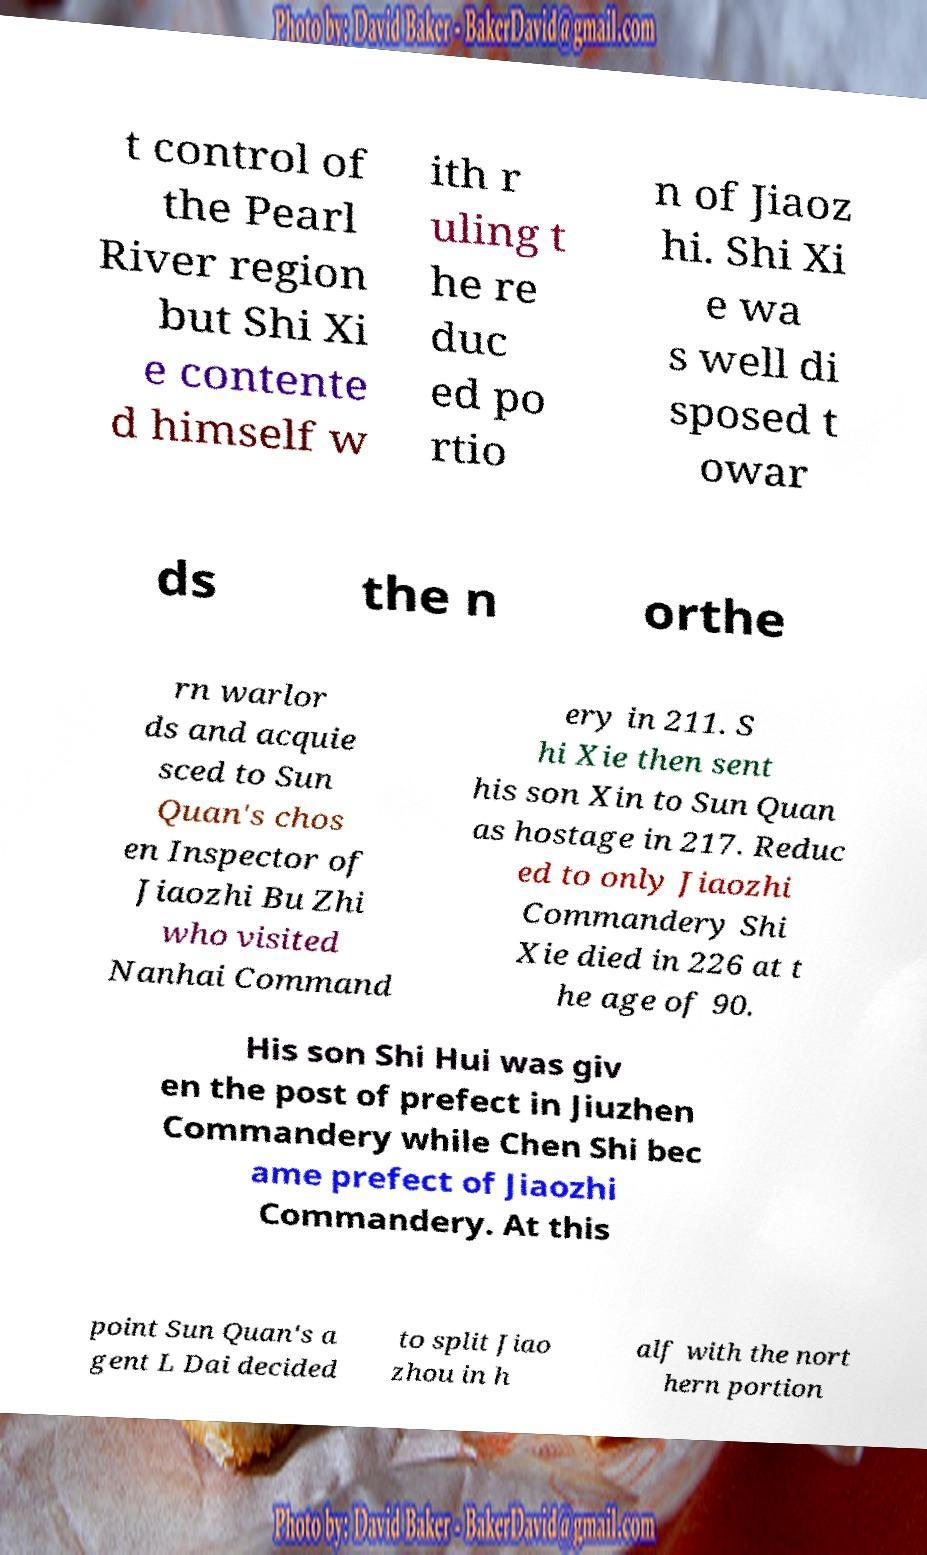I need the written content from this picture converted into text. Can you do that? t control of the Pearl River region but Shi Xi e contente d himself w ith r uling t he re duc ed po rtio n of Jiaoz hi. Shi Xi e wa s well di sposed t owar ds the n orthe rn warlor ds and acquie sced to Sun Quan's chos en Inspector of Jiaozhi Bu Zhi who visited Nanhai Command ery in 211. S hi Xie then sent his son Xin to Sun Quan as hostage in 217. Reduc ed to only Jiaozhi Commandery Shi Xie died in 226 at t he age of 90. His son Shi Hui was giv en the post of prefect in Jiuzhen Commandery while Chen Shi bec ame prefect of Jiaozhi Commandery. At this point Sun Quan's a gent L Dai decided to split Jiao zhou in h alf with the nort hern portion 